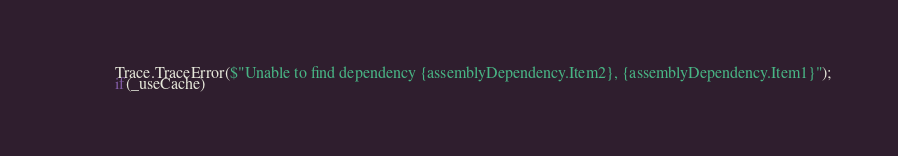Convert code to text. <code><loc_0><loc_0><loc_500><loc_500><_C#_>            Trace.TraceError($"Unable to find dependency {assemblyDependency.Item2}, {assemblyDependency.Item1}");
            if(_useCache)</code> 